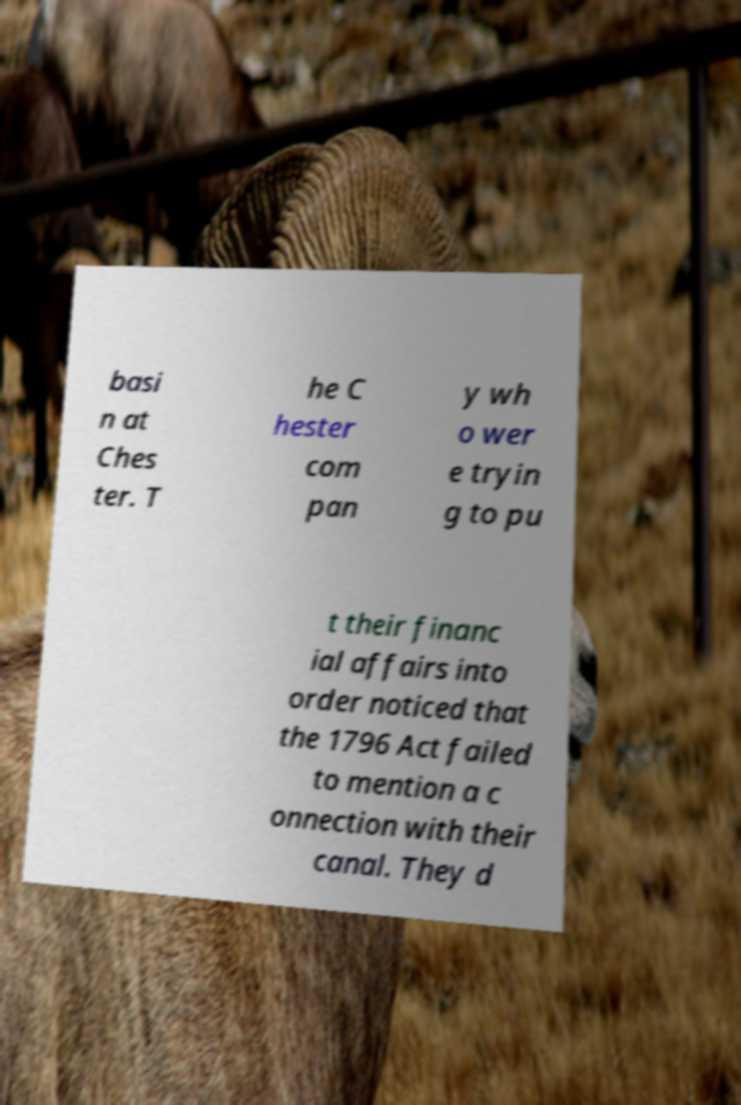There's text embedded in this image that I need extracted. Can you transcribe it verbatim? basi n at Ches ter. T he C hester com pan y wh o wer e tryin g to pu t their financ ial affairs into order noticed that the 1796 Act failed to mention a c onnection with their canal. They d 